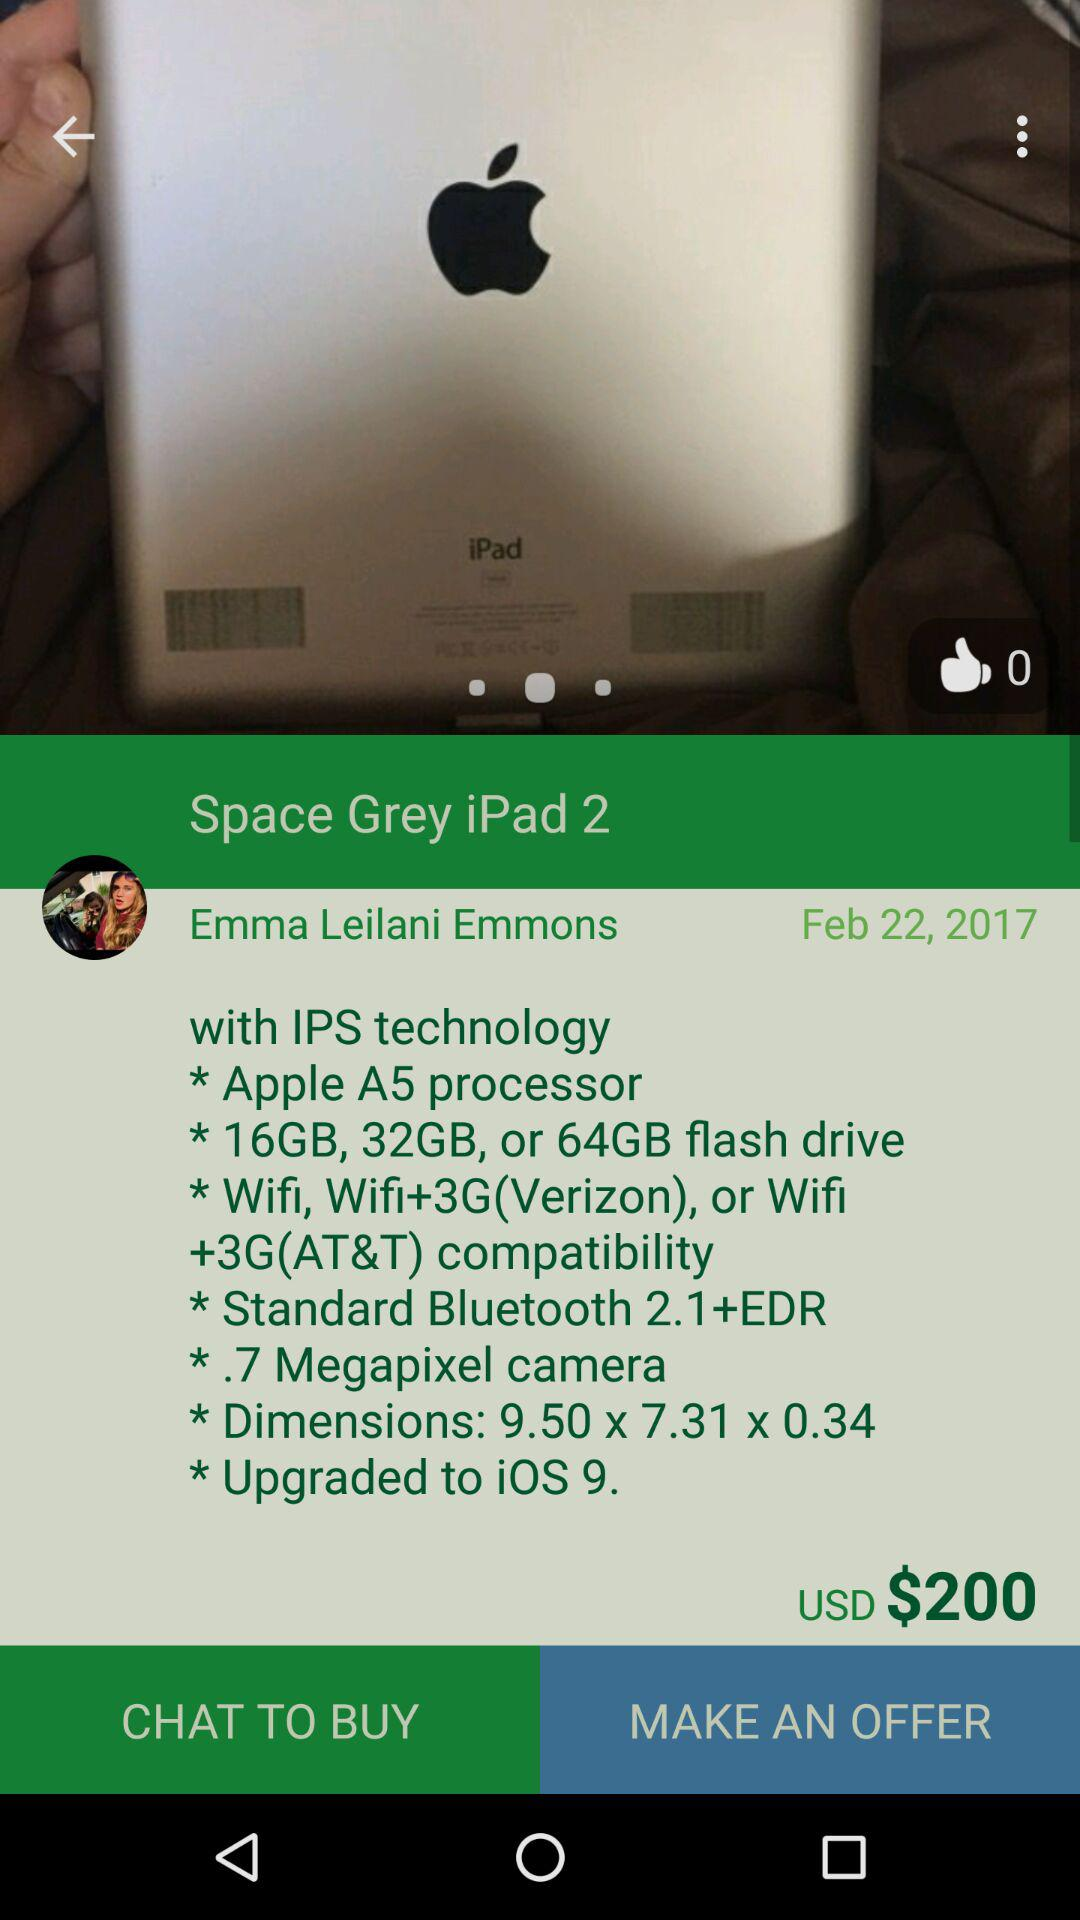How many more GB of storage does the 64GB iPad have than the 16GB iPad?
Answer the question using a single word or phrase. 48 